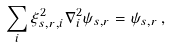<formula> <loc_0><loc_0><loc_500><loc_500>\sum _ { i } \xi _ { s , r , i } ^ { 2 } \nabla _ { i } ^ { 2 } \psi _ { s , r } = \psi _ { s , r } \, ,</formula> 